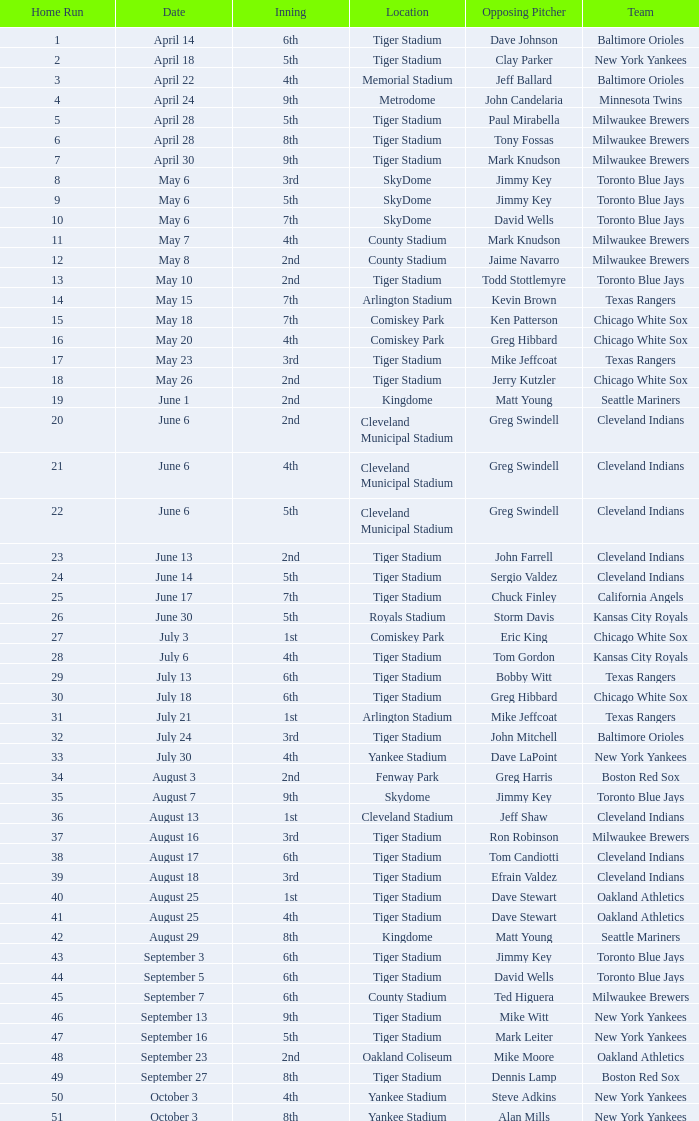On June 17 in Tiger stadium, what was the average home run? 25.0. Would you be able to parse every entry in this table? {'header': ['Home Run', 'Date', 'Inning', 'Location', 'Opposing Pitcher', 'Team'], 'rows': [['1', 'April 14', '6th', 'Tiger Stadium', 'Dave Johnson', 'Baltimore Orioles'], ['2', 'April 18', '5th', 'Tiger Stadium', 'Clay Parker', 'New York Yankees'], ['3', 'April 22', '4th', 'Memorial Stadium', 'Jeff Ballard', 'Baltimore Orioles'], ['4', 'April 24', '9th', 'Metrodome', 'John Candelaria', 'Minnesota Twins'], ['5', 'April 28', '5th', 'Tiger Stadium', 'Paul Mirabella', 'Milwaukee Brewers'], ['6', 'April 28', '8th', 'Tiger Stadium', 'Tony Fossas', 'Milwaukee Brewers'], ['7', 'April 30', '9th', 'Tiger Stadium', 'Mark Knudson', 'Milwaukee Brewers'], ['8', 'May 6', '3rd', 'SkyDome', 'Jimmy Key', 'Toronto Blue Jays'], ['9', 'May 6', '5th', 'SkyDome', 'Jimmy Key', 'Toronto Blue Jays'], ['10', 'May 6', '7th', 'SkyDome', 'David Wells', 'Toronto Blue Jays'], ['11', 'May 7', '4th', 'County Stadium', 'Mark Knudson', 'Milwaukee Brewers'], ['12', 'May 8', '2nd', 'County Stadium', 'Jaime Navarro', 'Milwaukee Brewers'], ['13', 'May 10', '2nd', 'Tiger Stadium', 'Todd Stottlemyre', 'Toronto Blue Jays'], ['14', 'May 15', '7th', 'Arlington Stadium', 'Kevin Brown', 'Texas Rangers'], ['15', 'May 18', '7th', 'Comiskey Park', 'Ken Patterson', 'Chicago White Sox'], ['16', 'May 20', '4th', 'Comiskey Park', 'Greg Hibbard', 'Chicago White Sox'], ['17', 'May 23', '3rd', 'Tiger Stadium', 'Mike Jeffcoat', 'Texas Rangers'], ['18', 'May 26', '2nd', 'Tiger Stadium', 'Jerry Kutzler', 'Chicago White Sox'], ['19', 'June 1', '2nd', 'Kingdome', 'Matt Young', 'Seattle Mariners'], ['20', 'June 6', '2nd', 'Cleveland Municipal Stadium', 'Greg Swindell', 'Cleveland Indians'], ['21', 'June 6', '4th', 'Cleveland Municipal Stadium', 'Greg Swindell', 'Cleveland Indians'], ['22', 'June 6', '5th', 'Cleveland Municipal Stadium', 'Greg Swindell', 'Cleveland Indians'], ['23', 'June 13', '2nd', 'Tiger Stadium', 'John Farrell', 'Cleveland Indians'], ['24', 'June 14', '5th', 'Tiger Stadium', 'Sergio Valdez', 'Cleveland Indians'], ['25', 'June 17', '7th', 'Tiger Stadium', 'Chuck Finley', 'California Angels'], ['26', 'June 30', '5th', 'Royals Stadium', 'Storm Davis', 'Kansas City Royals'], ['27', 'July 3', '1st', 'Comiskey Park', 'Eric King', 'Chicago White Sox'], ['28', 'July 6', '4th', 'Tiger Stadium', 'Tom Gordon', 'Kansas City Royals'], ['29', 'July 13', '6th', 'Tiger Stadium', 'Bobby Witt', 'Texas Rangers'], ['30', 'July 18', '6th', 'Tiger Stadium', 'Greg Hibbard', 'Chicago White Sox'], ['31', 'July 21', '1st', 'Arlington Stadium', 'Mike Jeffcoat', 'Texas Rangers'], ['32', 'July 24', '3rd', 'Tiger Stadium', 'John Mitchell', 'Baltimore Orioles'], ['33', 'July 30', '4th', 'Yankee Stadium', 'Dave LaPoint', 'New York Yankees'], ['34', 'August 3', '2nd', 'Fenway Park', 'Greg Harris', 'Boston Red Sox'], ['35', 'August 7', '9th', 'Skydome', 'Jimmy Key', 'Toronto Blue Jays'], ['36', 'August 13', '1st', 'Cleveland Stadium', 'Jeff Shaw', 'Cleveland Indians'], ['37', 'August 16', '3rd', 'Tiger Stadium', 'Ron Robinson', 'Milwaukee Brewers'], ['38', 'August 17', '6th', 'Tiger Stadium', 'Tom Candiotti', 'Cleveland Indians'], ['39', 'August 18', '3rd', 'Tiger Stadium', 'Efrain Valdez', 'Cleveland Indians'], ['40', 'August 25', '1st', 'Tiger Stadium', 'Dave Stewart', 'Oakland Athletics'], ['41', 'August 25', '4th', 'Tiger Stadium', 'Dave Stewart', 'Oakland Athletics'], ['42', 'August 29', '8th', 'Kingdome', 'Matt Young', 'Seattle Mariners'], ['43', 'September 3', '6th', 'Tiger Stadium', 'Jimmy Key', 'Toronto Blue Jays'], ['44', 'September 5', '6th', 'Tiger Stadium', 'David Wells', 'Toronto Blue Jays'], ['45', 'September 7', '6th', 'County Stadium', 'Ted Higuera', 'Milwaukee Brewers'], ['46', 'September 13', '9th', 'Tiger Stadium', 'Mike Witt', 'New York Yankees'], ['47', 'September 16', '5th', 'Tiger Stadium', 'Mark Leiter', 'New York Yankees'], ['48', 'September 23', '2nd', 'Oakland Coliseum', 'Mike Moore', 'Oakland Athletics'], ['49', 'September 27', '8th', 'Tiger Stadium', 'Dennis Lamp', 'Boston Red Sox'], ['50', 'October 3', '4th', 'Yankee Stadium', 'Steve Adkins', 'New York Yankees'], ['51', 'October 3', '8th', 'Yankee Stadium', 'Alan Mills', 'New York Yankees']]} 